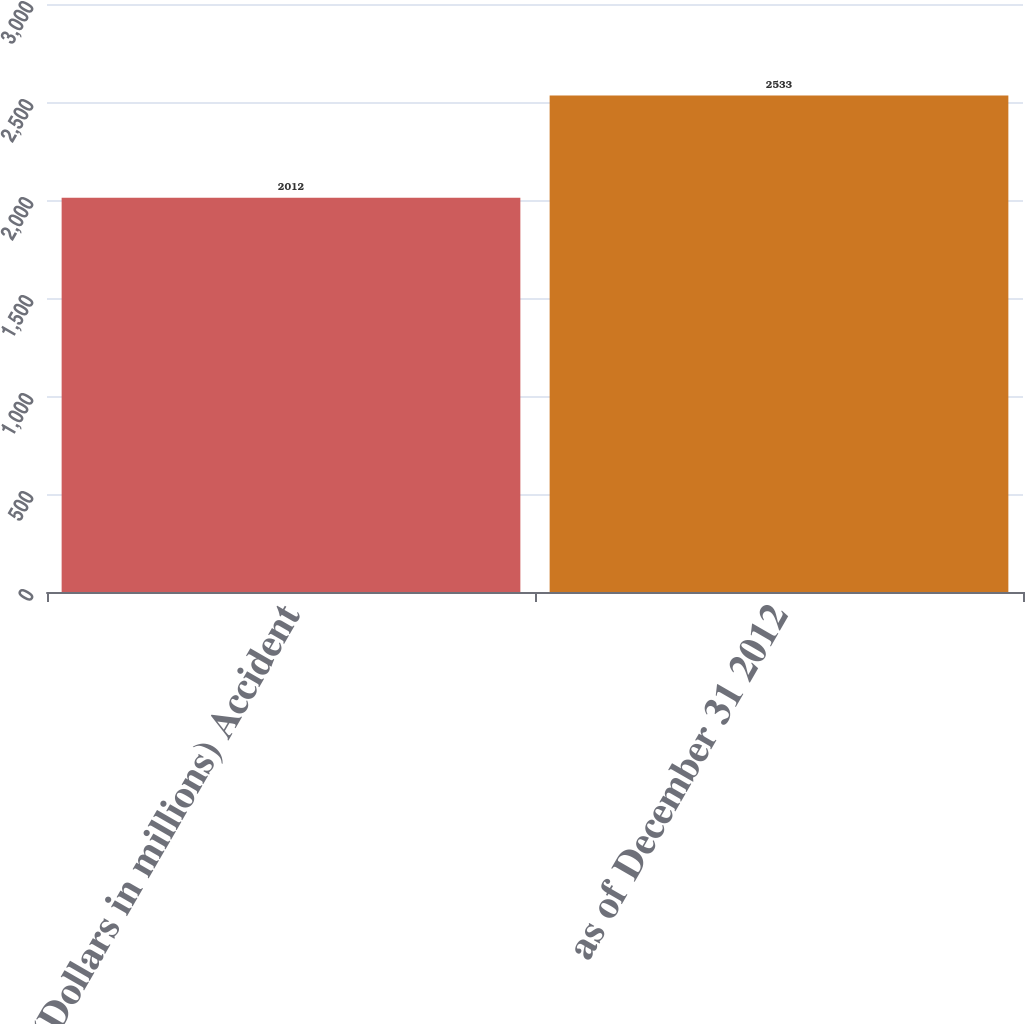Convert chart to OTSL. <chart><loc_0><loc_0><loc_500><loc_500><bar_chart><fcel>(Dollars in millions) Accident<fcel>as of December 31 2012<nl><fcel>2012<fcel>2533<nl></chart> 